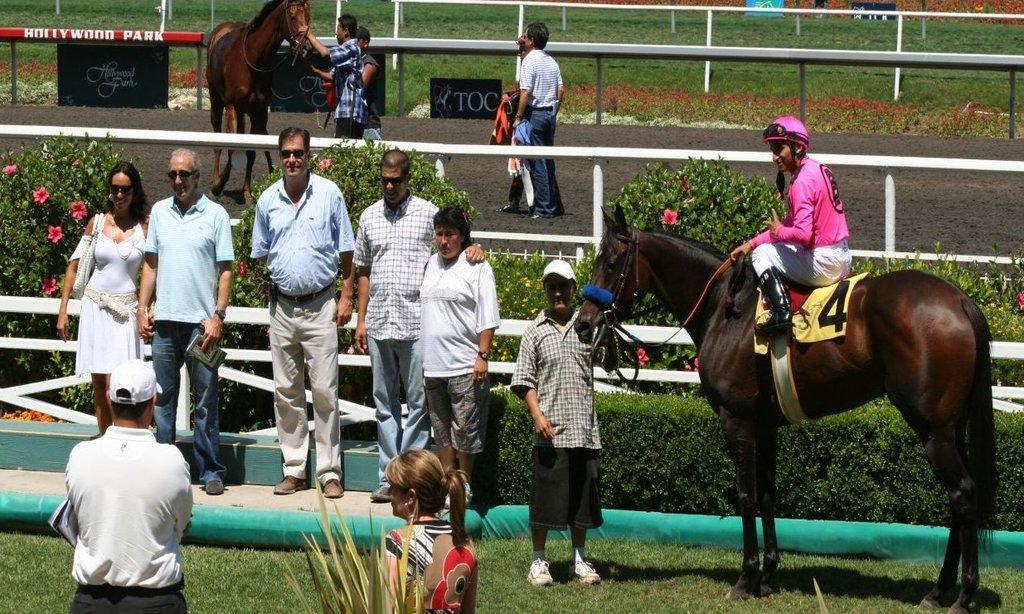How would you summarize this image in a sentence or two? In this image I see number of people, in which few of them are standing and this person is sitting on the horse. I can also see few plans and the grass over here and I see another horse over here. 